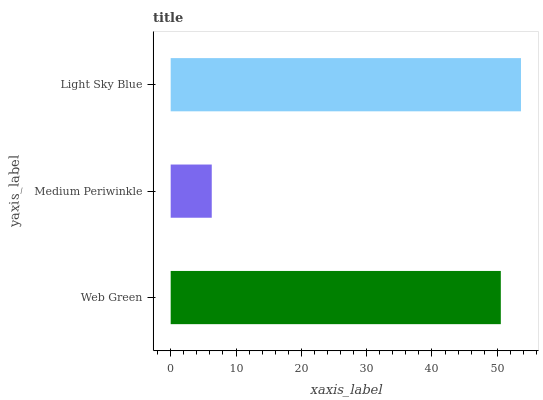Is Medium Periwinkle the minimum?
Answer yes or no. Yes. Is Light Sky Blue the maximum?
Answer yes or no. Yes. Is Light Sky Blue the minimum?
Answer yes or no. No. Is Medium Periwinkle the maximum?
Answer yes or no. No. Is Light Sky Blue greater than Medium Periwinkle?
Answer yes or no. Yes. Is Medium Periwinkle less than Light Sky Blue?
Answer yes or no. Yes. Is Medium Periwinkle greater than Light Sky Blue?
Answer yes or no. No. Is Light Sky Blue less than Medium Periwinkle?
Answer yes or no. No. Is Web Green the high median?
Answer yes or no. Yes. Is Web Green the low median?
Answer yes or no. Yes. Is Light Sky Blue the high median?
Answer yes or no. No. Is Light Sky Blue the low median?
Answer yes or no. No. 